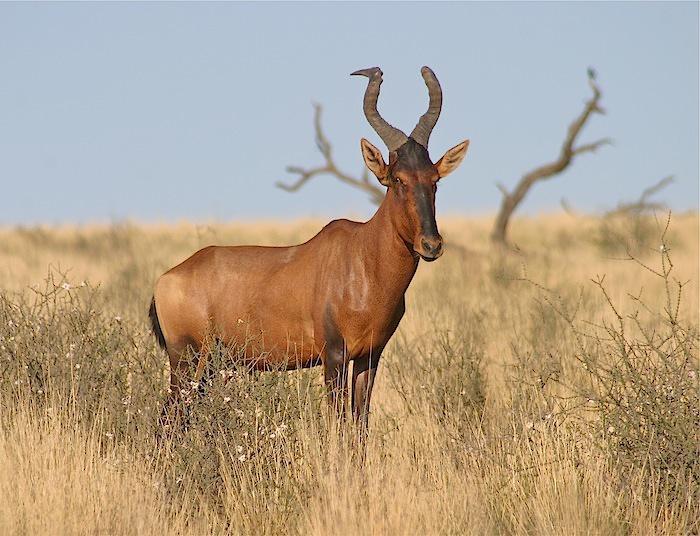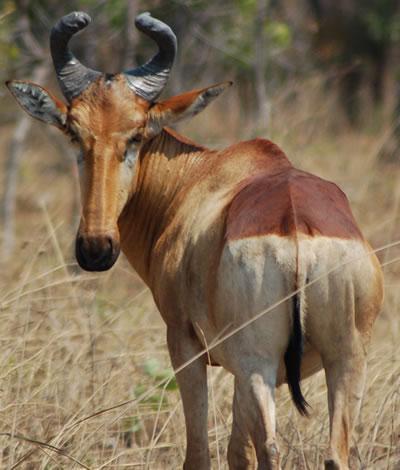The first image is the image on the left, the second image is the image on the right. For the images displayed, is the sentence "All animals are oriented/facing the same direction." factually correct? Answer yes or no. No. The first image is the image on the left, the second image is the image on the right. For the images displayed, is the sentence "Each image contains one horned animal, and the animals on the left and right have their bodies turned in the same general direction." factually correct? Answer yes or no. No. 